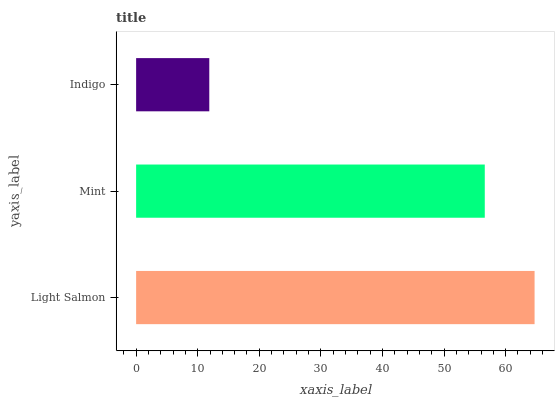Is Indigo the minimum?
Answer yes or no. Yes. Is Light Salmon the maximum?
Answer yes or no. Yes. Is Mint the minimum?
Answer yes or no. No. Is Mint the maximum?
Answer yes or no. No. Is Light Salmon greater than Mint?
Answer yes or no. Yes. Is Mint less than Light Salmon?
Answer yes or no. Yes. Is Mint greater than Light Salmon?
Answer yes or no. No. Is Light Salmon less than Mint?
Answer yes or no. No. Is Mint the high median?
Answer yes or no. Yes. Is Mint the low median?
Answer yes or no. Yes. Is Light Salmon the high median?
Answer yes or no. No. Is Indigo the low median?
Answer yes or no. No. 